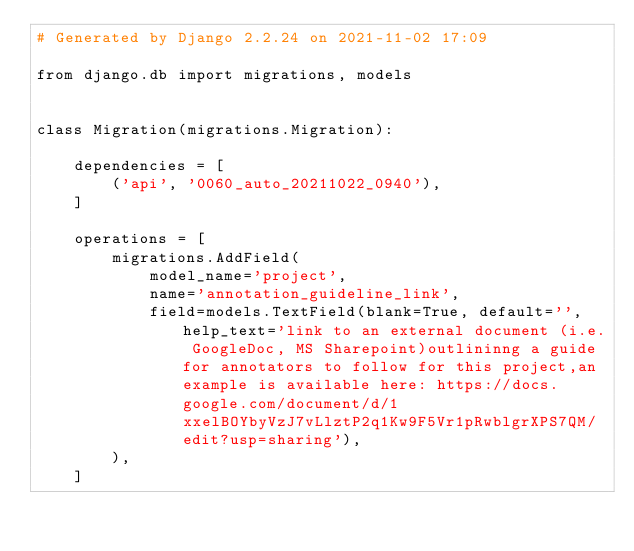<code> <loc_0><loc_0><loc_500><loc_500><_Python_># Generated by Django 2.2.24 on 2021-11-02 17:09

from django.db import migrations, models


class Migration(migrations.Migration):

    dependencies = [
        ('api', '0060_auto_20211022_0940'),
    ]

    operations = [
        migrations.AddField(
            model_name='project',
            name='annotation_guideline_link',
            field=models.TextField(blank=True, default='', help_text='link to an external document (i.e. GoogleDoc, MS Sharepoint)outlininng a guide for annotators to follow for this project,an example is available here: https://docs.google.com/document/d/1xxelBOYbyVzJ7vLlztP2q1Kw9F5Vr1pRwblgrXPS7QM/edit?usp=sharing'),
        ),
    ]
</code> 